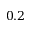Convert formula to latex. <formula><loc_0><loc_0><loc_500><loc_500>0 . 2</formula> 